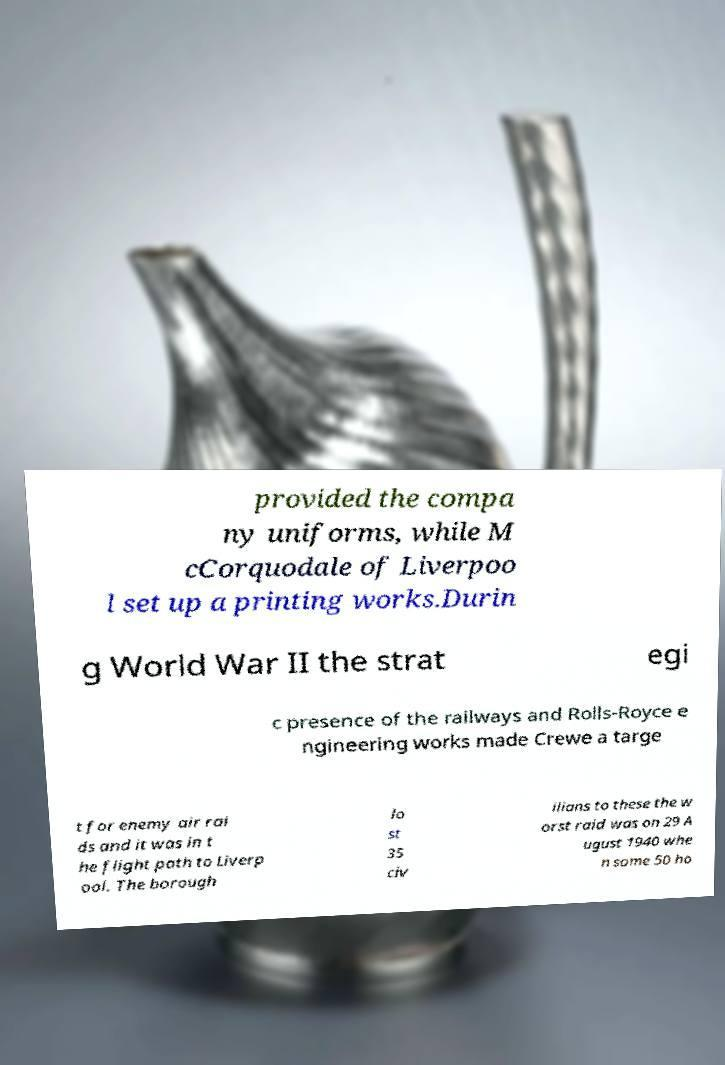Please identify and transcribe the text found in this image. provided the compa ny uniforms, while M cCorquodale of Liverpoo l set up a printing works.Durin g World War II the strat egi c presence of the railways and Rolls-Royce e ngineering works made Crewe a targe t for enemy air rai ds and it was in t he flight path to Liverp ool. The borough lo st 35 civ ilians to these the w orst raid was on 29 A ugust 1940 whe n some 50 ho 